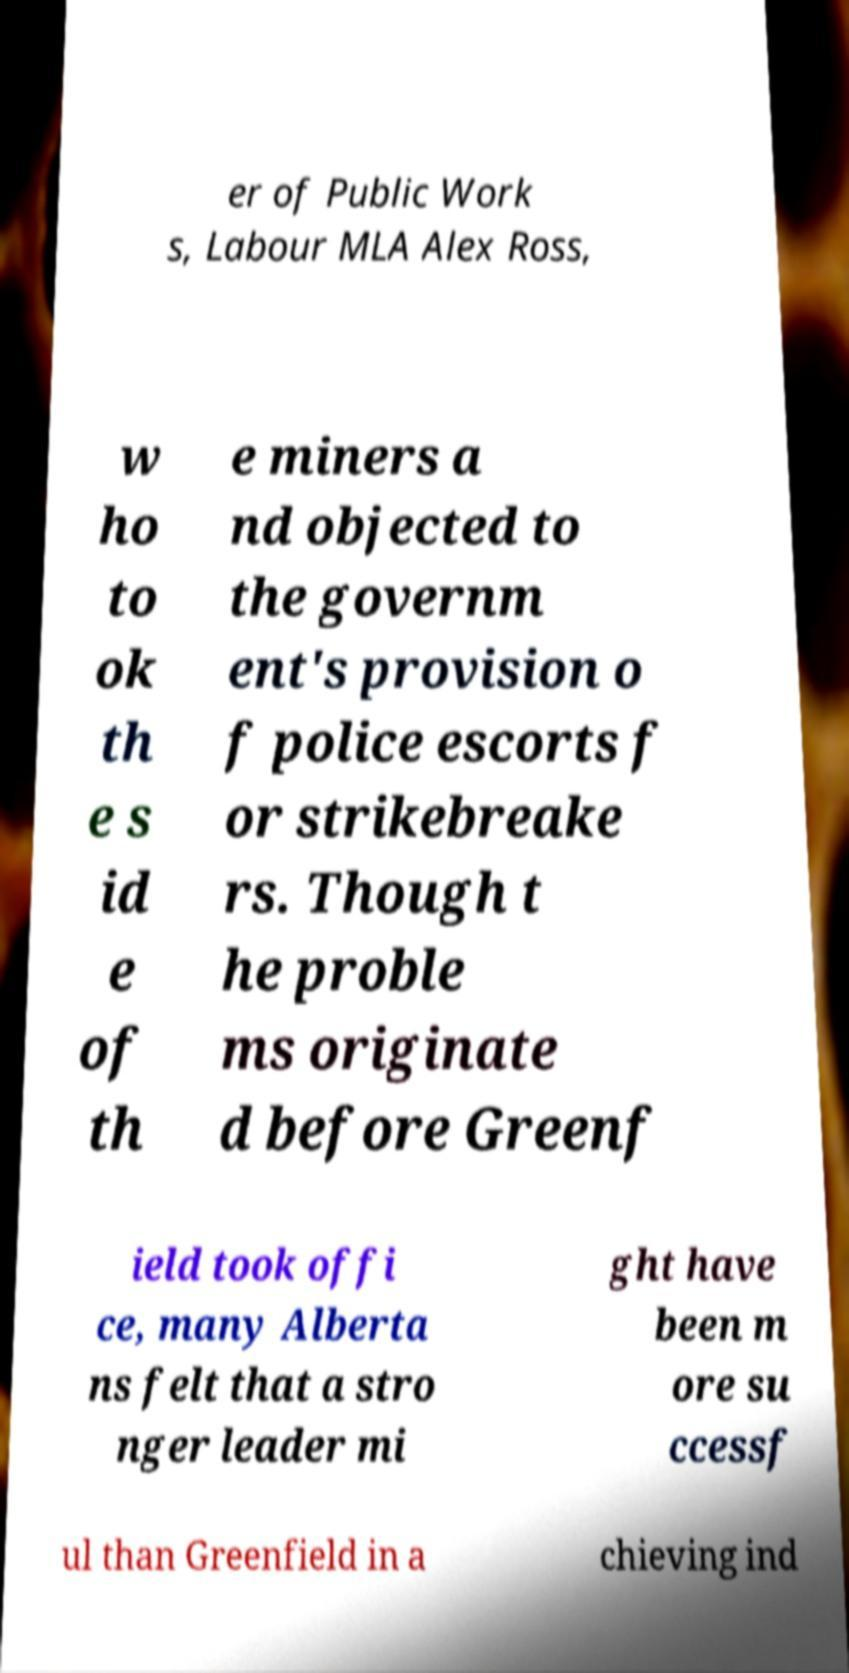I need the written content from this picture converted into text. Can you do that? er of Public Work s, Labour MLA Alex Ross, w ho to ok th e s id e of th e miners a nd objected to the governm ent's provision o f police escorts f or strikebreake rs. Though t he proble ms originate d before Greenf ield took offi ce, many Alberta ns felt that a stro nger leader mi ght have been m ore su ccessf ul than Greenfield in a chieving ind 